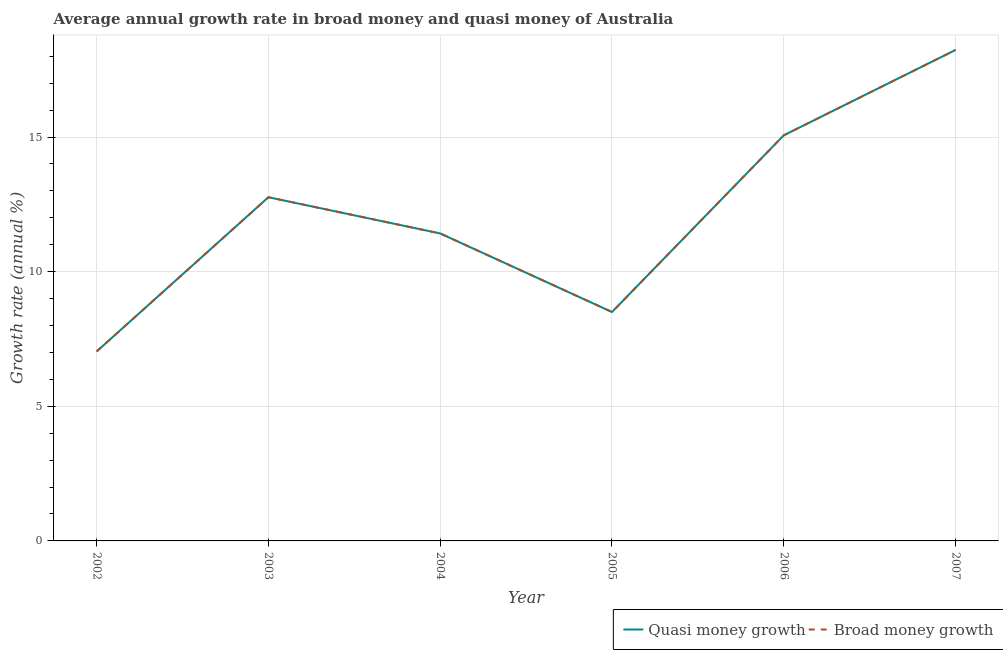Does the line corresponding to annual growth rate in quasi money intersect with the line corresponding to annual growth rate in broad money?
Keep it short and to the point. Yes. Is the number of lines equal to the number of legend labels?
Provide a short and direct response. Yes. What is the annual growth rate in broad money in 2004?
Make the answer very short. 11.42. Across all years, what is the maximum annual growth rate in broad money?
Give a very brief answer. 18.23. Across all years, what is the minimum annual growth rate in broad money?
Keep it short and to the point. 7.04. In which year was the annual growth rate in broad money maximum?
Your answer should be compact. 2007. What is the total annual growth rate in quasi money in the graph?
Offer a very short reply. 73.01. What is the difference between the annual growth rate in quasi money in 2004 and that in 2005?
Keep it short and to the point. 2.92. What is the difference between the annual growth rate in broad money in 2003 and the annual growth rate in quasi money in 2002?
Offer a very short reply. 5.73. What is the average annual growth rate in quasi money per year?
Your answer should be very brief. 12.17. What is the ratio of the annual growth rate in quasi money in 2004 to that in 2007?
Make the answer very short. 0.63. Is the annual growth rate in quasi money in 2002 less than that in 2007?
Give a very brief answer. Yes. Is the difference between the annual growth rate in quasi money in 2004 and 2007 greater than the difference between the annual growth rate in broad money in 2004 and 2007?
Your answer should be compact. No. What is the difference between the highest and the second highest annual growth rate in broad money?
Your answer should be compact. 3.17. What is the difference between the highest and the lowest annual growth rate in quasi money?
Keep it short and to the point. 11.2. Is the sum of the annual growth rate in quasi money in 2004 and 2007 greater than the maximum annual growth rate in broad money across all years?
Provide a succinct answer. Yes. Does the annual growth rate in broad money monotonically increase over the years?
Make the answer very short. No. How many lines are there?
Provide a short and direct response. 2. How many years are there in the graph?
Make the answer very short. 6. What is the difference between two consecutive major ticks on the Y-axis?
Offer a terse response. 5. Does the graph contain any zero values?
Your answer should be very brief. No. How many legend labels are there?
Provide a short and direct response. 2. What is the title of the graph?
Give a very brief answer. Average annual growth rate in broad money and quasi money of Australia. What is the label or title of the X-axis?
Your answer should be compact. Year. What is the label or title of the Y-axis?
Your answer should be very brief. Growth rate (annual %). What is the Growth rate (annual %) of Quasi money growth in 2002?
Ensure brevity in your answer.  7.04. What is the Growth rate (annual %) of Broad money growth in 2002?
Ensure brevity in your answer.  7.04. What is the Growth rate (annual %) in Quasi money growth in 2003?
Your response must be concise. 12.76. What is the Growth rate (annual %) of Broad money growth in 2003?
Make the answer very short. 12.76. What is the Growth rate (annual %) in Quasi money growth in 2004?
Provide a short and direct response. 11.42. What is the Growth rate (annual %) of Broad money growth in 2004?
Offer a very short reply. 11.42. What is the Growth rate (annual %) of Quasi money growth in 2005?
Your answer should be compact. 8.5. What is the Growth rate (annual %) in Broad money growth in 2005?
Keep it short and to the point. 8.5. What is the Growth rate (annual %) in Quasi money growth in 2006?
Offer a terse response. 15.06. What is the Growth rate (annual %) of Broad money growth in 2006?
Ensure brevity in your answer.  15.06. What is the Growth rate (annual %) of Quasi money growth in 2007?
Your answer should be very brief. 18.23. What is the Growth rate (annual %) of Broad money growth in 2007?
Give a very brief answer. 18.23. Across all years, what is the maximum Growth rate (annual %) of Quasi money growth?
Your response must be concise. 18.23. Across all years, what is the maximum Growth rate (annual %) in Broad money growth?
Your response must be concise. 18.23. Across all years, what is the minimum Growth rate (annual %) in Quasi money growth?
Provide a succinct answer. 7.04. Across all years, what is the minimum Growth rate (annual %) in Broad money growth?
Keep it short and to the point. 7.04. What is the total Growth rate (annual %) in Quasi money growth in the graph?
Your answer should be very brief. 73.01. What is the total Growth rate (annual %) of Broad money growth in the graph?
Your response must be concise. 73.01. What is the difference between the Growth rate (annual %) in Quasi money growth in 2002 and that in 2003?
Keep it short and to the point. -5.73. What is the difference between the Growth rate (annual %) in Broad money growth in 2002 and that in 2003?
Provide a short and direct response. -5.73. What is the difference between the Growth rate (annual %) of Quasi money growth in 2002 and that in 2004?
Provide a succinct answer. -4.38. What is the difference between the Growth rate (annual %) in Broad money growth in 2002 and that in 2004?
Give a very brief answer. -4.38. What is the difference between the Growth rate (annual %) in Quasi money growth in 2002 and that in 2005?
Your answer should be very brief. -1.46. What is the difference between the Growth rate (annual %) in Broad money growth in 2002 and that in 2005?
Keep it short and to the point. -1.46. What is the difference between the Growth rate (annual %) in Quasi money growth in 2002 and that in 2006?
Give a very brief answer. -8.03. What is the difference between the Growth rate (annual %) in Broad money growth in 2002 and that in 2006?
Give a very brief answer. -8.03. What is the difference between the Growth rate (annual %) of Quasi money growth in 2002 and that in 2007?
Provide a succinct answer. -11.2. What is the difference between the Growth rate (annual %) of Broad money growth in 2002 and that in 2007?
Keep it short and to the point. -11.2. What is the difference between the Growth rate (annual %) of Quasi money growth in 2003 and that in 2004?
Give a very brief answer. 1.35. What is the difference between the Growth rate (annual %) of Broad money growth in 2003 and that in 2004?
Keep it short and to the point. 1.35. What is the difference between the Growth rate (annual %) in Quasi money growth in 2003 and that in 2005?
Your answer should be very brief. 4.26. What is the difference between the Growth rate (annual %) in Broad money growth in 2003 and that in 2005?
Your response must be concise. 4.26. What is the difference between the Growth rate (annual %) of Quasi money growth in 2003 and that in 2006?
Ensure brevity in your answer.  -2.3. What is the difference between the Growth rate (annual %) of Broad money growth in 2003 and that in 2006?
Provide a short and direct response. -2.3. What is the difference between the Growth rate (annual %) of Quasi money growth in 2003 and that in 2007?
Your answer should be compact. -5.47. What is the difference between the Growth rate (annual %) in Broad money growth in 2003 and that in 2007?
Give a very brief answer. -5.47. What is the difference between the Growth rate (annual %) of Quasi money growth in 2004 and that in 2005?
Offer a terse response. 2.92. What is the difference between the Growth rate (annual %) in Broad money growth in 2004 and that in 2005?
Your answer should be very brief. 2.92. What is the difference between the Growth rate (annual %) in Quasi money growth in 2004 and that in 2006?
Your response must be concise. -3.64. What is the difference between the Growth rate (annual %) in Broad money growth in 2004 and that in 2006?
Offer a terse response. -3.64. What is the difference between the Growth rate (annual %) in Quasi money growth in 2004 and that in 2007?
Provide a short and direct response. -6.81. What is the difference between the Growth rate (annual %) of Broad money growth in 2004 and that in 2007?
Give a very brief answer. -6.81. What is the difference between the Growth rate (annual %) in Quasi money growth in 2005 and that in 2006?
Give a very brief answer. -6.56. What is the difference between the Growth rate (annual %) of Broad money growth in 2005 and that in 2006?
Your answer should be very brief. -6.56. What is the difference between the Growth rate (annual %) in Quasi money growth in 2005 and that in 2007?
Keep it short and to the point. -9.73. What is the difference between the Growth rate (annual %) in Broad money growth in 2005 and that in 2007?
Give a very brief answer. -9.73. What is the difference between the Growth rate (annual %) of Quasi money growth in 2006 and that in 2007?
Your answer should be compact. -3.17. What is the difference between the Growth rate (annual %) of Broad money growth in 2006 and that in 2007?
Give a very brief answer. -3.17. What is the difference between the Growth rate (annual %) in Quasi money growth in 2002 and the Growth rate (annual %) in Broad money growth in 2003?
Offer a very short reply. -5.73. What is the difference between the Growth rate (annual %) in Quasi money growth in 2002 and the Growth rate (annual %) in Broad money growth in 2004?
Your answer should be very brief. -4.38. What is the difference between the Growth rate (annual %) of Quasi money growth in 2002 and the Growth rate (annual %) of Broad money growth in 2005?
Provide a short and direct response. -1.46. What is the difference between the Growth rate (annual %) in Quasi money growth in 2002 and the Growth rate (annual %) in Broad money growth in 2006?
Ensure brevity in your answer.  -8.03. What is the difference between the Growth rate (annual %) of Quasi money growth in 2002 and the Growth rate (annual %) of Broad money growth in 2007?
Provide a succinct answer. -11.2. What is the difference between the Growth rate (annual %) of Quasi money growth in 2003 and the Growth rate (annual %) of Broad money growth in 2004?
Give a very brief answer. 1.35. What is the difference between the Growth rate (annual %) in Quasi money growth in 2003 and the Growth rate (annual %) in Broad money growth in 2005?
Give a very brief answer. 4.26. What is the difference between the Growth rate (annual %) in Quasi money growth in 2003 and the Growth rate (annual %) in Broad money growth in 2006?
Make the answer very short. -2.3. What is the difference between the Growth rate (annual %) in Quasi money growth in 2003 and the Growth rate (annual %) in Broad money growth in 2007?
Provide a succinct answer. -5.47. What is the difference between the Growth rate (annual %) of Quasi money growth in 2004 and the Growth rate (annual %) of Broad money growth in 2005?
Your response must be concise. 2.92. What is the difference between the Growth rate (annual %) of Quasi money growth in 2004 and the Growth rate (annual %) of Broad money growth in 2006?
Give a very brief answer. -3.64. What is the difference between the Growth rate (annual %) of Quasi money growth in 2004 and the Growth rate (annual %) of Broad money growth in 2007?
Keep it short and to the point. -6.81. What is the difference between the Growth rate (annual %) in Quasi money growth in 2005 and the Growth rate (annual %) in Broad money growth in 2006?
Your answer should be compact. -6.56. What is the difference between the Growth rate (annual %) of Quasi money growth in 2005 and the Growth rate (annual %) of Broad money growth in 2007?
Offer a terse response. -9.73. What is the difference between the Growth rate (annual %) of Quasi money growth in 2006 and the Growth rate (annual %) of Broad money growth in 2007?
Offer a terse response. -3.17. What is the average Growth rate (annual %) of Quasi money growth per year?
Your answer should be very brief. 12.17. What is the average Growth rate (annual %) of Broad money growth per year?
Provide a succinct answer. 12.17. In the year 2002, what is the difference between the Growth rate (annual %) in Quasi money growth and Growth rate (annual %) in Broad money growth?
Your answer should be compact. 0. In the year 2004, what is the difference between the Growth rate (annual %) of Quasi money growth and Growth rate (annual %) of Broad money growth?
Give a very brief answer. 0. In the year 2005, what is the difference between the Growth rate (annual %) of Quasi money growth and Growth rate (annual %) of Broad money growth?
Keep it short and to the point. 0. In the year 2007, what is the difference between the Growth rate (annual %) of Quasi money growth and Growth rate (annual %) of Broad money growth?
Offer a terse response. 0. What is the ratio of the Growth rate (annual %) in Quasi money growth in 2002 to that in 2003?
Provide a short and direct response. 0.55. What is the ratio of the Growth rate (annual %) in Broad money growth in 2002 to that in 2003?
Your answer should be compact. 0.55. What is the ratio of the Growth rate (annual %) in Quasi money growth in 2002 to that in 2004?
Offer a terse response. 0.62. What is the ratio of the Growth rate (annual %) in Broad money growth in 2002 to that in 2004?
Offer a terse response. 0.62. What is the ratio of the Growth rate (annual %) of Quasi money growth in 2002 to that in 2005?
Give a very brief answer. 0.83. What is the ratio of the Growth rate (annual %) of Broad money growth in 2002 to that in 2005?
Provide a short and direct response. 0.83. What is the ratio of the Growth rate (annual %) in Quasi money growth in 2002 to that in 2006?
Make the answer very short. 0.47. What is the ratio of the Growth rate (annual %) in Broad money growth in 2002 to that in 2006?
Your answer should be very brief. 0.47. What is the ratio of the Growth rate (annual %) of Quasi money growth in 2002 to that in 2007?
Offer a terse response. 0.39. What is the ratio of the Growth rate (annual %) in Broad money growth in 2002 to that in 2007?
Provide a succinct answer. 0.39. What is the ratio of the Growth rate (annual %) in Quasi money growth in 2003 to that in 2004?
Keep it short and to the point. 1.12. What is the ratio of the Growth rate (annual %) of Broad money growth in 2003 to that in 2004?
Your response must be concise. 1.12. What is the ratio of the Growth rate (annual %) of Quasi money growth in 2003 to that in 2005?
Give a very brief answer. 1.5. What is the ratio of the Growth rate (annual %) of Broad money growth in 2003 to that in 2005?
Ensure brevity in your answer.  1.5. What is the ratio of the Growth rate (annual %) in Quasi money growth in 2003 to that in 2006?
Offer a terse response. 0.85. What is the ratio of the Growth rate (annual %) of Broad money growth in 2003 to that in 2006?
Your answer should be compact. 0.85. What is the ratio of the Growth rate (annual %) in Quasi money growth in 2003 to that in 2007?
Give a very brief answer. 0.7. What is the ratio of the Growth rate (annual %) of Broad money growth in 2003 to that in 2007?
Offer a very short reply. 0.7. What is the ratio of the Growth rate (annual %) in Quasi money growth in 2004 to that in 2005?
Your response must be concise. 1.34. What is the ratio of the Growth rate (annual %) of Broad money growth in 2004 to that in 2005?
Your answer should be compact. 1.34. What is the ratio of the Growth rate (annual %) of Quasi money growth in 2004 to that in 2006?
Ensure brevity in your answer.  0.76. What is the ratio of the Growth rate (annual %) in Broad money growth in 2004 to that in 2006?
Make the answer very short. 0.76. What is the ratio of the Growth rate (annual %) in Quasi money growth in 2004 to that in 2007?
Keep it short and to the point. 0.63. What is the ratio of the Growth rate (annual %) in Broad money growth in 2004 to that in 2007?
Your answer should be very brief. 0.63. What is the ratio of the Growth rate (annual %) of Quasi money growth in 2005 to that in 2006?
Give a very brief answer. 0.56. What is the ratio of the Growth rate (annual %) of Broad money growth in 2005 to that in 2006?
Offer a very short reply. 0.56. What is the ratio of the Growth rate (annual %) of Quasi money growth in 2005 to that in 2007?
Offer a very short reply. 0.47. What is the ratio of the Growth rate (annual %) of Broad money growth in 2005 to that in 2007?
Make the answer very short. 0.47. What is the ratio of the Growth rate (annual %) of Quasi money growth in 2006 to that in 2007?
Offer a very short reply. 0.83. What is the ratio of the Growth rate (annual %) in Broad money growth in 2006 to that in 2007?
Your answer should be very brief. 0.83. What is the difference between the highest and the second highest Growth rate (annual %) in Quasi money growth?
Provide a short and direct response. 3.17. What is the difference between the highest and the second highest Growth rate (annual %) of Broad money growth?
Make the answer very short. 3.17. What is the difference between the highest and the lowest Growth rate (annual %) in Quasi money growth?
Give a very brief answer. 11.2. What is the difference between the highest and the lowest Growth rate (annual %) in Broad money growth?
Your answer should be very brief. 11.2. 